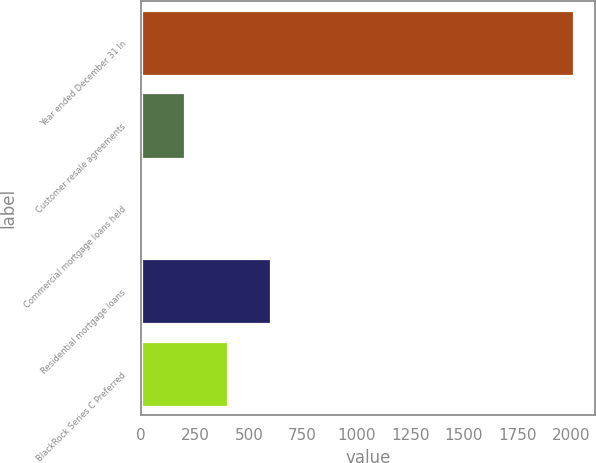<chart> <loc_0><loc_0><loc_500><loc_500><bar_chart><fcel>Year ended December 31 In<fcel>Customer resale agreements<fcel>Commercial mortgage loans held<fcel>Residential mortgage loans<fcel>BlackRock Series C Preferred<nl><fcel>2011<fcel>203.8<fcel>3<fcel>605.4<fcel>404.6<nl></chart> 